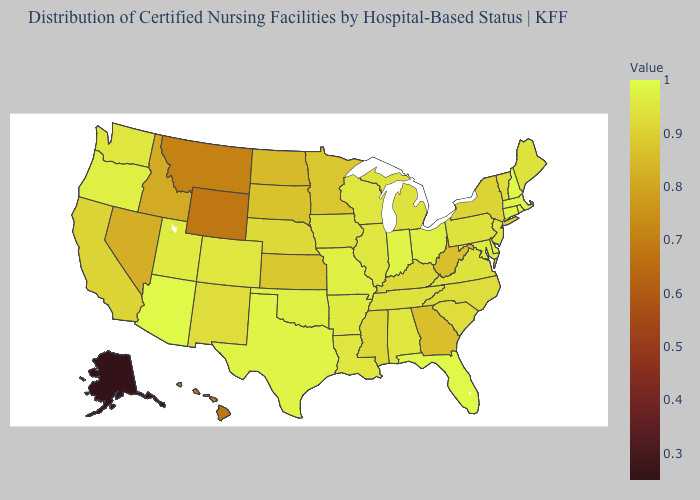Among the states that border Rhode Island , which have the highest value?
Write a very short answer. Connecticut, Massachusetts. Which states have the lowest value in the MidWest?
Short answer required. North Dakota. Which states have the lowest value in the South?
Answer briefly. Georgia, West Virginia. Among the states that border Indiana , which have the highest value?
Be succinct. Ohio. Among the states that border Vermont , which have the lowest value?
Short answer required. New York. Among the states that border North Carolina , which have the lowest value?
Be succinct. Georgia. 